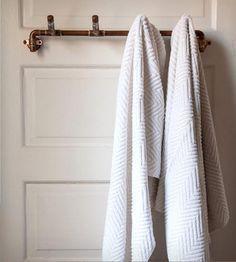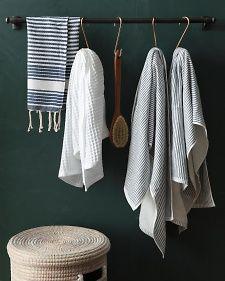The first image is the image on the left, the second image is the image on the right. For the images shown, is this caption "In one of the images, the towels are hung on something mounted to a wooden board along the wall." true? Answer yes or no. No. The first image is the image on the left, the second image is the image on the right. Examine the images to the left and right. Is the description "There are two hanging towels in the left image." accurate? Answer yes or no. Yes. 